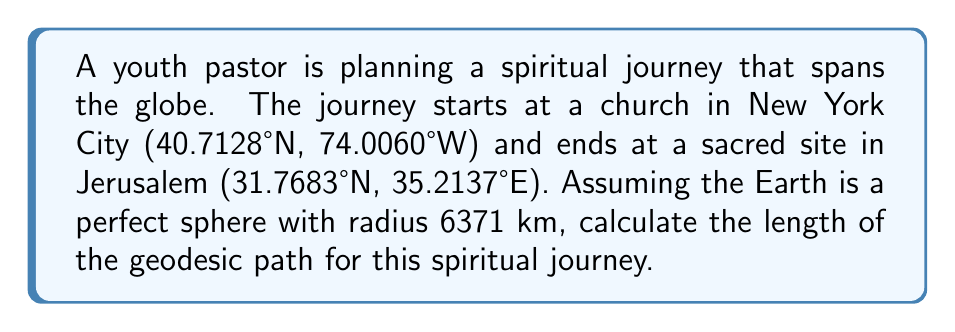Show me your answer to this math problem. To solve this problem, we'll use the spherical law of cosines to find the central angle between the two points, then calculate the arc length along the great circle.

Step 1: Convert the coordinates to radians.
New York: $\phi_1 = 40.7128° \times \frac{\pi}{180} = 0.7102$ rad, $\lambda_1 = -74.0060° \times \frac{\pi}{180} = -1.2917$ rad
Jerusalem: $\phi_2 = 31.7683° \times \frac{\pi}{180} = 0.5545$ rad, $\lambda_2 = 35.2137° \times \frac{\pi}{180} = 0.6146$ rad

Step 2: Calculate the central angle $\theta$ using the spherical law of cosines:
$$\cos(\theta) = \sin(\phi_1)\sin(\phi_2) + \cos(\phi_1)\cos(\phi_2)\cos(\lambda_2 - \lambda_1)$$

$$\theta = \arccos(\sin(0.7102)\sin(0.5545) + \cos(0.7102)\cos(0.5545)\cos(0.6146 - (-1.2917)))$$

$$\theta = \arccos(0.3918 + 0.5686 \times 0.8264) = 0.9597 \text{ rad}$$

Step 3: Calculate the arc length $s$ using the formula $s = R\theta$, where $R$ is the Earth's radius:

$$s = 6371 \text{ km} \times 0.9597 \text{ rad} = 6114.5 \text{ km}$$

Therefore, the length of the geodesic path for the spiritual journey is approximately 6114.5 km.
Answer: 6114.5 km 